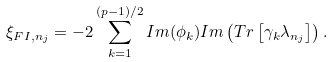<formula> <loc_0><loc_0><loc_500><loc_500>\xi _ { { F I } , n _ { j } } = - 2 \sum _ { k = 1 } ^ { ( p - 1 ) / 2 } I m ( \phi _ { k } ) I m \left ( T r \left [ \gamma _ { k } \lambda _ { n _ { j } } \right ] \right ) .</formula> 